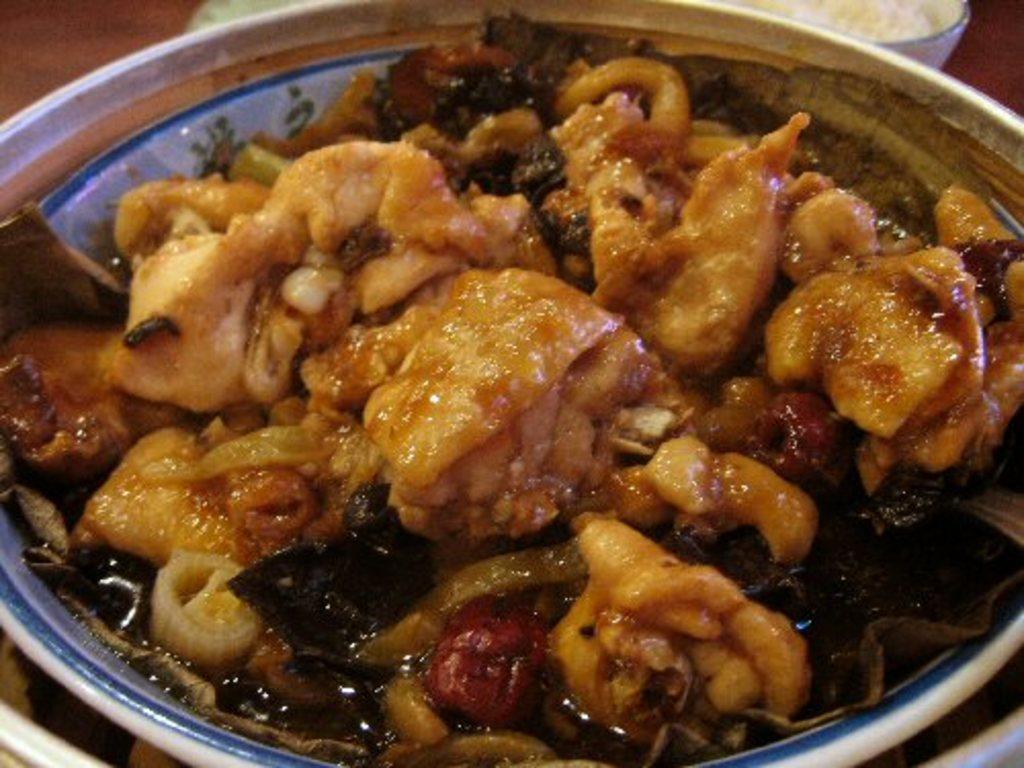Could you give a brief overview of what you see in this image? This image consists of a bowl. In that there are some eatables. This is placed on a table. 